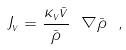<formula> <loc_0><loc_0><loc_500><loc_500>J _ { v } = \frac { \kappa _ { v } \bar { v } } { \bar { \rho } } \ \nabla \bar { \rho } \ ,</formula> 